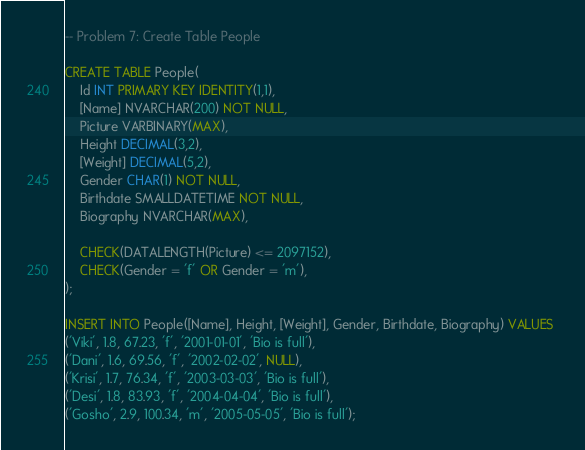Convert code to text. <code><loc_0><loc_0><loc_500><loc_500><_SQL_>-- Problem 7: Create Table People

CREATE TABLE People(
    Id INT PRIMARY KEY IDENTITY(1,1),
    [Name] NVARCHAR(200) NOT NULL,
    Picture VARBINARY(MAX),
    Height DECIMAL(3,2),
    [Weight] DECIMAL(5,2),
    Gender CHAR(1) NOT NULL,
	Birthdate SMALLDATETIME NOT NULL,
	Biography NVARCHAR(MAX),
	
	CHECK(DATALENGTH(Picture) <= 2097152),
	CHECK(Gender = 'f' OR Gender = 'm'),
);

INSERT INTO People([Name], Height, [Weight], Gender, Birthdate, Biography) VALUES 
('Viki', 1.8, 67.23, 'f', '2001-01-01', 'Bio is full'),
('Dani', 1.6, 69.56, 'f', '2002-02-02', NULL),
('Krisi', 1.7, 76.34, 'f', '2003-03-03', 'Bio is full'),
('Desi', 1.8, 83.93, 'f', '2004-04-04', 'Bio is full'),
('Gosho', 2.9, 100.34, 'm', '2005-05-05', 'Bio is full');
</code> 